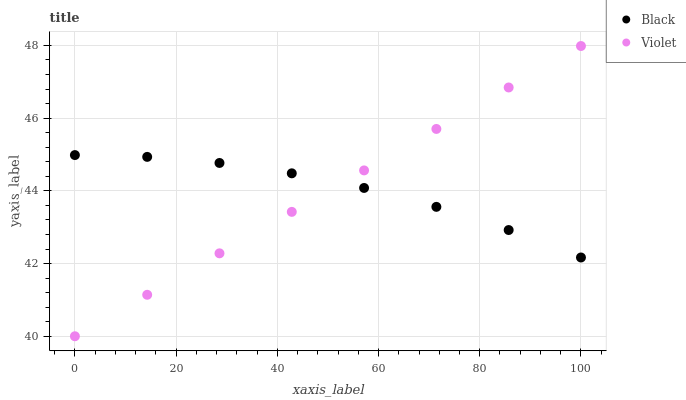Does Violet have the minimum area under the curve?
Answer yes or no. Yes. Does Black have the maximum area under the curve?
Answer yes or no. Yes. Does Violet have the maximum area under the curve?
Answer yes or no. No. Is Violet the smoothest?
Answer yes or no. Yes. Is Black the roughest?
Answer yes or no. Yes. Is Violet the roughest?
Answer yes or no. No. Does Violet have the lowest value?
Answer yes or no. Yes. Does Violet have the highest value?
Answer yes or no. Yes. Does Black intersect Violet?
Answer yes or no. Yes. Is Black less than Violet?
Answer yes or no. No. Is Black greater than Violet?
Answer yes or no. No. 